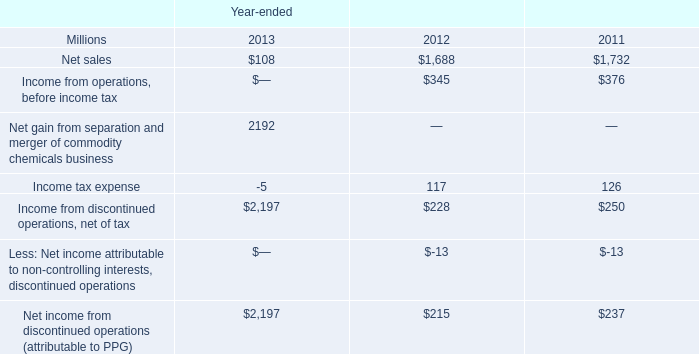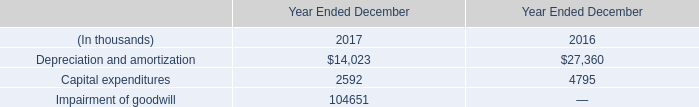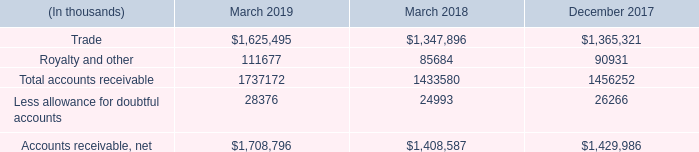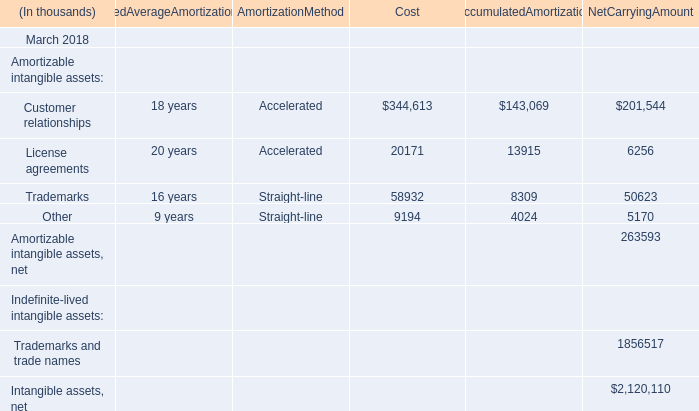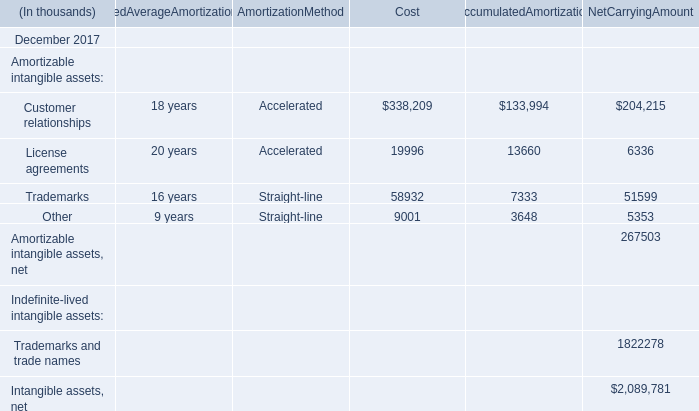What do all Cost sum up, excluding those negative ones in 2018? (in thousand) 
Computations: (((344613 + 20171) + 58932) + 9194)
Answer: 432910.0. 